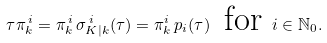Convert formula to latex. <formula><loc_0><loc_0><loc_500><loc_500>\tau \pi _ { k } ^ { \, i } = \pi _ { k } ^ { \, i } \, \sigma _ { K | k } ^ { \, i } ( \tau ) = \pi _ { k } ^ { i } \, p _ { i } ( \tau ) \, \text { for } i \in \mathbb { N } _ { 0 } .</formula> 